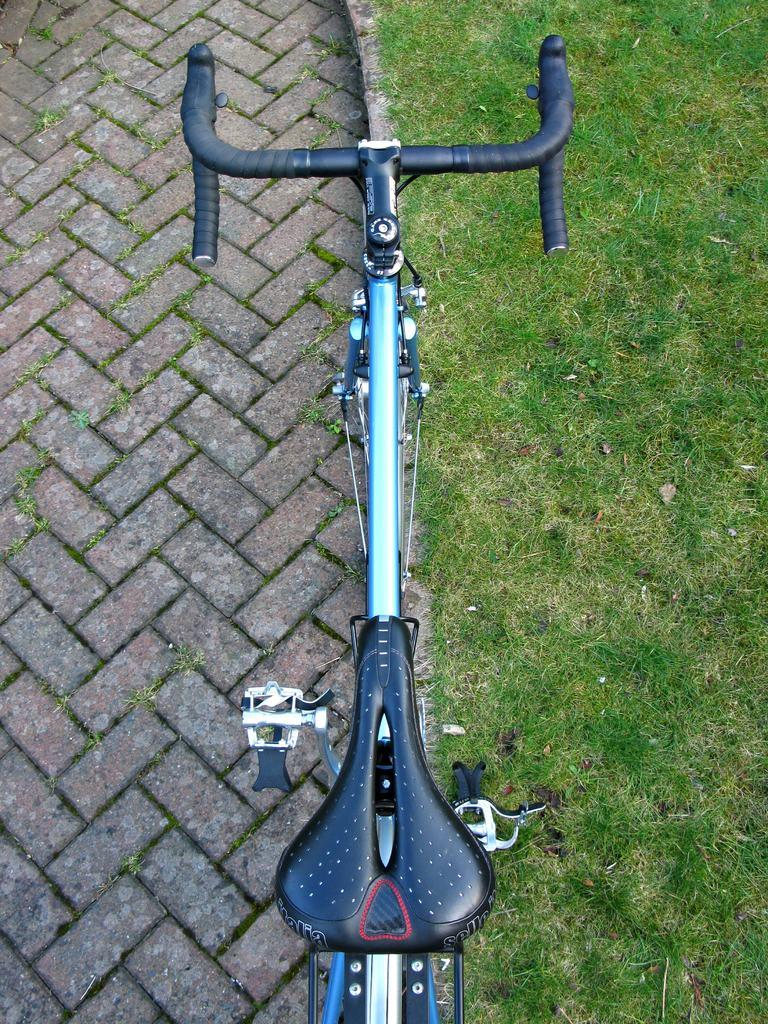What type of surface is visible on the ground in the image? There is grass on the ground in the image. What mode of transportation can be seen in the image? There is a blue and black bicycle in the image. Where is the bicycle located in the image? The bicycle is on the road. What type of industry is depicted in the image? There is no industry depicted in the image; it features grass, a bicycle, and a road. What brand of toothpaste is advertised on the bicycle in the image? There is no toothpaste or advertisement present on the bicycle in the image. 